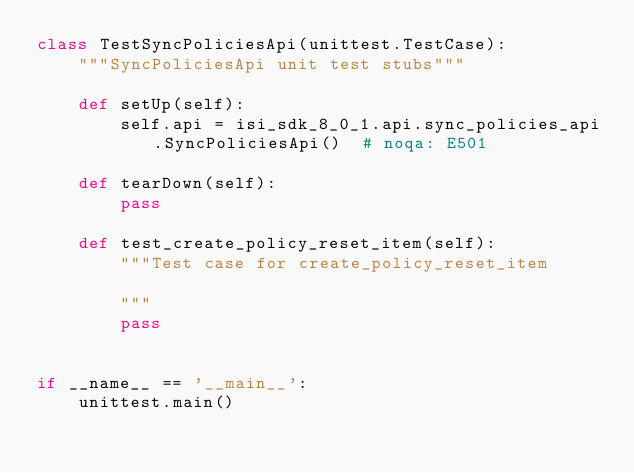Convert code to text. <code><loc_0><loc_0><loc_500><loc_500><_Python_>class TestSyncPoliciesApi(unittest.TestCase):
    """SyncPoliciesApi unit test stubs"""

    def setUp(self):
        self.api = isi_sdk_8_0_1.api.sync_policies_api.SyncPoliciesApi()  # noqa: E501

    def tearDown(self):
        pass

    def test_create_policy_reset_item(self):
        """Test case for create_policy_reset_item

        """
        pass


if __name__ == '__main__':
    unittest.main()
</code> 